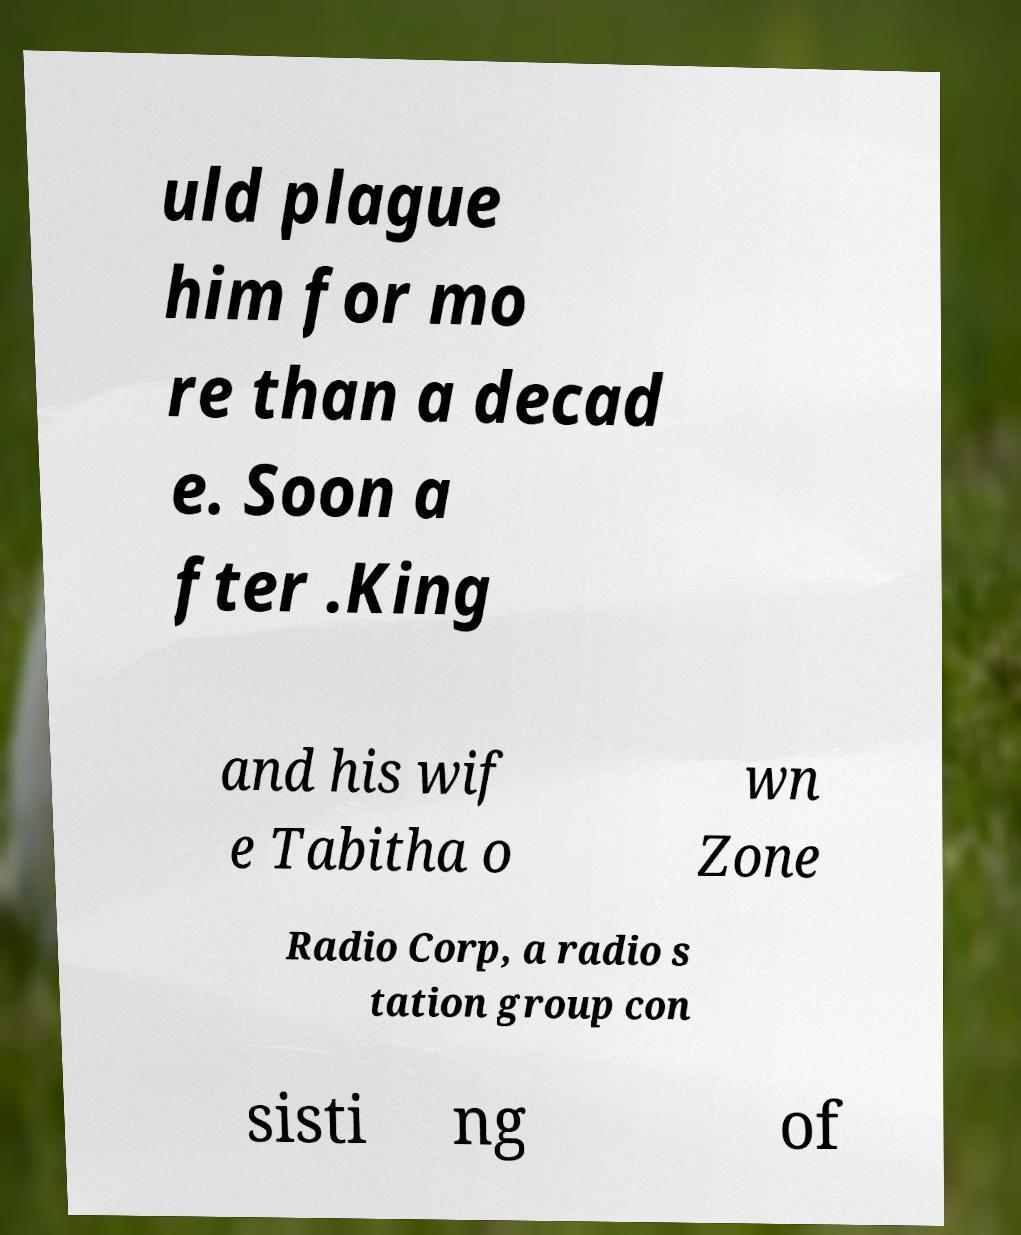For documentation purposes, I need the text within this image transcribed. Could you provide that? uld plague him for mo re than a decad e. Soon a fter .King and his wif e Tabitha o wn Zone Radio Corp, a radio s tation group con sisti ng of 